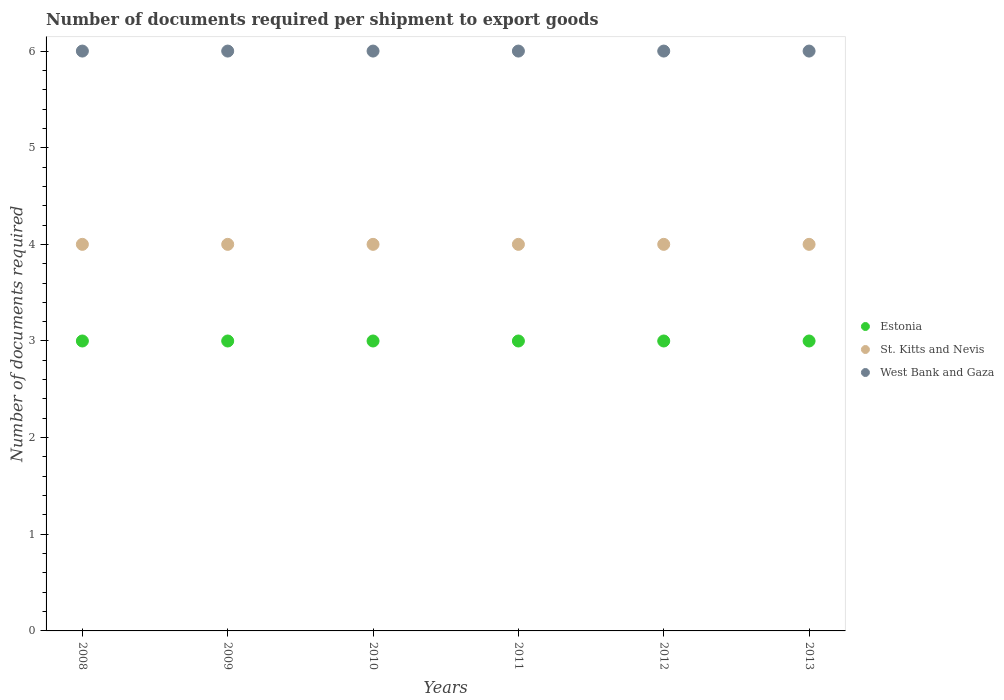How many different coloured dotlines are there?
Offer a terse response. 3. Is the number of dotlines equal to the number of legend labels?
Your answer should be very brief. Yes. In which year was the number of documents required per shipment to export goods in Estonia minimum?
Provide a short and direct response. 2008. What is the total number of documents required per shipment to export goods in St. Kitts and Nevis in the graph?
Provide a short and direct response. 24. What is the difference between the number of documents required per shipment to export goods in Estonia in 2008 and that in 2010?
Offer a terse response. 0. What is the difference between the number of documents required per shipment to export goods in West Bank and Gaza in 2013 and the number of documents required per shipment to export goods in St. Kitts and Nevis in 2012?
Make the answer very short. 2. In the year 2012, what is the difference between the number of documents required per shipment to export goods in Estonia and number of documents required per shipment to export goods in West Bank and Gaza?
Make the answer very short. -3. What is the ratio of the number of documents required per shipment to export goods in West Bank and Gaza in 2010 to that in 2011?
Provide a succinct answer. 1. Is the number of documents required per shipment to export goods in St. Kitts and Nevis in 2008 less than that in 2013?
Offer a very short reply. No. Is the difference between the number of documents required per shipment to export goods in Estonia in 2008 and 2009 greater than the difference between the number of documents required per shipment to export goods in West Bank and Gaza in 2008 and 2009?
Ensure brevity in your answer.  No. What is the difference between the highest and the second highest number of documents required per shipment to export goods in Estonia?
Your answer should be compact. 0. Is the sum of the number of documents required per shipment to export goods in Estonia in 2008 and 2013 greater than the maximum number of documents required per shipment to export goods in St. Kitts and Nevis across all years?
Provide a short and direct response. Yes. Is it the case that in every year, the sum of the number of documents required per shipment to export goods in St. Kitts and Nevis and number of documents required per shipment to export goods in Estonia  is greater than the number of documents required per shipment to export goods in West Bank and Gaza?
Ensure brevity in your answer.  Yes. Are the values on the major ticks of Y-axis written in scientific E-notation?
Provide a succinct answer. No. Does the graph contain grids?
Your response must be concise. No. Where does the legend appear in the graph?
Provide a short and direct response. Center right. How many legend labels are there?
Your answer should be very brief. 3. How are the legend labels stacked?
Ensure brevity in your answer.  Vertical. What is the title of the graph?
Your answer should be compact. Number of documents required per shipment to export goods. What is the label or title of the Y-axis?
Keep it short and to the point. Number of documents required. What is the Number of documents required of Estonia in 2008?
Provide a succinct answer. 3. What is the Number of documents required in West Bank and Gaza in 2008?
Offer a terse response. 6. What is the Number of documents required of Estonia in 2009?
Provide a short and direct response. 3. What is the Number of documents required of St. Kitts and Nevis in 2009?
Your answer should be very brief. 4. What is the Number of documents required in West Bank and Gaza in 2010?
Offer a terse response. 6. What is the Number of documents required of St. Kitts and Nevis in 2012?
Your answer should be very brief. 4. What is the Number of documents required in St. Kitts and Nevis in 2013?
Your answer should be compact. 4. Across all years, what is the maximum Number of documents required in Estonia?
Offer a very short reply. 3. Across all years, what is the maximum Number of documents required of St. Kitts and Nevis?
Keep it short and to the point. 4. Across all years, what is the minimum Number of documents required in Estonia?
Give a very brief answer. 3. Across all years, what is the minimum Number of documents required of St. Kitts and Nevis?
Your answer should be compact. 4. Across all years, what is the minimum Number of documents required of West Bank and Gaza?
Provide a succinct answer. 6. What is the total Number of documents required of St. Kitts and Nevis in the graph?
Make the answer very short. 24. What is the total Number of documents required in West Bank and Gaza in the graph?
Keep it short and to the point. 36. What is the difference between the Number of documents required of Estonia in 2008 and that in 2009?
Your answer should be compact. 0. What is the difference between the Number of documents required in St. Kitts and Nevis in 2008 and that in 2009?
Your answer should be compact. 0. What is the difference between the Number of documents required in West Bank and Gaza in 2008 and that in 2009?
Provide a succinct answer. 0. What is the difference between the Number of documents required of St. Kitts and Nevis in 2008 and that in 2010?
Your answer should be very brief. 0. What is the difference between the Number of documents required in West Bank and Gaza in 2008 and that in 2010?
Ensure brevity in your answer.  0. What is the difference between the Number of documents required in Estonia in 2008 and that in 2011?
Make the answer very short. 0. What is the difference between the Number of documents required of Estonia in 2008 and that in 2012?
Give a very brief answer. 0. What is the difference between the Number of documents required in West Bank and Gaza in 2009 and that in 2010?
Provide a succinct answer. 0. What is the difference between the Number of documents required in Estonia in 2009 and that in 2011?
Your response must be concise. 0. What is the difference between the Number of documents required of West Bank and Gaza in 2009 and that in 2011?
Provide a short and direct response. 0. What is the difference between the Number of documents required in West Bank and Gaza in 2009 and that in 2012?
Provide a short and direct response. 0. What is the difference between the Number of documents required in West Bank and Gaza in 2009 and that in 2013?
Your answer should be very brief. 0. What is the difference between the Number of documents required in Estonia in 2010 and that in 2011?
Offer a terse response. 0. What is the difference between the Number of documents required of West Bank and Gaza in 2010 and that in 2011?
Provide a succinct answer. 0. What is the difference between the Number of documents required of West Bank and Gaza in 2010 and that in 2012?
Offer a very short reply. 0. What is the difference between the Number of documents required of Estonia in 2011 and that in 2013?
Your answer should be compact. 0. What is the difference between the Number of documents required in St. Kitts and Nevis in 2011 and that in 2013?
Your response must be concise. 0. What is the difference between the Number of documents required of St. Kitts and Nevis in 2012 and that in 2013?
Offer a terse response. 0. What is the difference between the Number of documents required in St. Kitts and Nevis in 2008 and the Number of documents required in West Bank and Gaza in 2009?
Ensure brevity in your answer.  -2. What is the difference between the Number of documents required in Estonia in 2008 and the Number of documents required in West Bank and Gaza in 2010?
Offer a very short reply. -3. What is the difference between the Number of documents required in Estonia in 2008 and the Number of documents required in St. Kitts and Nevis in 2011?
Ensure brevity in your answer.  -1. What is the difference between the Number of documents required in St. Kitts and Nevis in 2008 and the Number of documents required in West Bank and Gaza in 2011?
Offer a very short reply. -2. What is the difference between the Number of documents required of Estonia in 2008 and the Number of documents required of West Bank and Gaza in 2012?
Your answer should be compact. -3. What is the difference between the Number of documents required in St. Kitts and Nevis in 2008 and the Number of documents required in West Bank and Gaza in 2012?
Ensure brevity in your answer.  -2. What is the difference between the Number of documents required of St. Kitts and Nevis in 2008 and the Number of documents required of West Bank and Gaza in 2013?
Ensure brevity in your answer.  -2. What is the difference between the Number of documents required in St. Kitts and Nevis in 2009 and the Number of documents required in West Bank and Gaza in 2010?
Provide a succinct answer. -2. What is the difference between the Number of documents required in Estonia in 2009 and the Number of documents required in West Bank and Gaza in 2011?
Make the answer very short. -3. What is the difference between the Number of documents required in Estonia in 2009 and the Number of documents required in St. Kitts and Nevis in 2012?
Offer a terse response. -1. What is the difference between the Number of documents required in Estonia in 2009 and the Number of documents required in West Bank and Gaza in 2012?
Your response must be concise. -3. What is the difference between the Number of documents required in St. Kitts and Nevis in 2009 and the Number of documents required in West Bank and Gaza in 2012?
Your answer should be compact. -2. What is the difference between the Number of documents required in Estonia in 2009 and the Number of documents required in St. Kitts and Nevis in 2013?
Your answer should be compact. -1. What is the difference between the Number of documents required of St. Kitts and Nevis in 2010 and the Number of documents required of West Bank and Gaza in 2011?
Provide a short and direct response. -2. What is the difference between the Number of documents required of Estonia in 2010 and the Number of documents required of West Bank and Gaza in 2012?
Give a very brief answer. -3. What is the difference between the Number of documents required of St. Kitts and Nevis in 2010 and the Number of documents required of West Bank and Gaza in 2012?
Offer a very short reply. -2. What is the difference between the Number of documents required in Estonia in 2010 and the Number of documents required in West Bank and Gaza in 2013?
Provide a succinct answer. -3. What is the difference between the Number of documents required of St. Kitts and Nevis in 2010 and the Number of documents required of West Bank and Gaza in 2013?
Your answer should be very brief. -2. What is the difference between the Number of documents required of St. Kitts and Nevis in 2011 and the Number of documents required of West Bank and Gaza in 2012?
Your answer should be very brief. -2. What is the difference between the Number of documents required of Estonia in 2011 and the Number of documents required of St. Kitts and Nevis in 2013?
Offer a very short reply. -1. What is the difference between the Number of documents required of Estonia in 2011 and the Number of documents required of West Bank and Gaza in 2013?
Offer a very short reply. -3. What is the difference between the Number of documents required of St. Kitts and Nevis in 2011 and the Number of documents required of West Bank and Gaza in 2013?
Offer a terse response. -2. What is the difference between the Number of documents required in St. Kitts and Nevis in 2012 and the Number of documents required in West Bank and Gaza in 2013?
Make the answer very short. -2. What is the average Number of documents required in Estonia per year?
Provide a short and direct response. 3. What is the average Number of documents required in West Bank and Gaza per year?
Make the answer very short. 6. In the year 2008, what is the difference between the Number of documents required in Estonia and Number of documents required in St. Kitts and Nevis?
Your answer should be compact. -1. In the year 2009, what is the difference between the Number of documents required of Estonia and Number of documents required of St. Kitts and Nevis?
Make the answer very short. -1. In the year 2009, what is the difference between the Number of documents required of Estonia and Number of documents required of West Bank and Gaza?
Give a very brief answer. -3. In the year 2009, what is the difference between the Number of documents required in St. Kitts and Nevis and Number of documents required in West Bank and Gaza?
Keep it short and to the point. -2. In the year 2010, what is the difference between the Number of documents required of Estonia and Number of documents required of St. Kitts and Nevis?
Provide a succinct answer. -1. In the year 2010, what is the difference between the Number of documents required in Estonia and Number of documents required in West Bank and Gaza?
Provide a short and direct response. -3. In the year 2011, what is the difference between the Number of documents required in St. Kitts and Nevis and Number of documents required in West Bank and Gaza?
Provide a short and direct response. -2. In the year 2012, what is the difference between the Number of documents required of Estonia and Number of documents required of St. Kitts and Nevis?
Ensure brevity in your answer.  -1. In the year 2012, what is the difference between the Number of documents required of St. Kitts and Nevis and Number of documents required of West Bank and Gaza?
Ensure brevity in your answer.  -2. In the year 2013, what is the difference between the Number of documents required of St. Kitts and Nevis and Number of documents required of West Bank and Gaza?
Your response must be concise. -2. What is the ratio of the Number of documents required in Estonia in 2008 to that in 2009?
Offer a very short reply. 1. What is the ratio of the Number of documents required in St. Kitts and Nevis in 2008 to that in 2010?
Your response must be concise. 1. What is the ratio of the Number of documents required of Estonia in 2008 to that in 2011?
Your response must be concise. 1. What is the ratio of the Number of documents required of West Bank and Gaza in 2008 to that in 2012?
Give a very brief answer. 1. What is the ratio of the Number of documents required of Estonia in 2008 to that in 2013?
Provide a succinct answer. 1. What is the ratio of the Number of documents required in West Bank and Gaza in 2008 to that in 2013?
Provide a short and direct response. 1. What is the ratio of the Number of documents required in St. Kitts and Nevis in 2009 to that in 2010?
Give a very brief answer. 1. What is the ratio of the Number of documents required of West Bank and Gaza in 2009 to that in 2010?
Give a very brief answer. 1. What is the ratio of the Number of documents required in Estonia in 2009 to that in 2011?
Keep it short and to the point. 1. What is the ratio of the Number of documents required of St. Kitts and Nevis in 2009 to that in 2011?
Ensure brevity in your answer.  1. What is the ratio of the Number of documents required in West Bank and Gaza in 2009 to that in 2011?
Your response must be concise. 1. What is the ratio of the Number of documents required of Estonia in 2009 to that in 2013?
Provide a succinct answer. 1. What is the ratio of the Number of documents required of St. Kitts and Nevis in 2009 to that in 2013?
Give a very brief answer. 1. What is the ratio of the Number of documents required of West Bank and Gaza in 2010 to that in 2011?
Ensure brevity in your answer.  1. What is the ratio of the Number of documents required of Estonia in 2010 to that in 2012?
Provide a succinct answer. 1. What is the ratio of the Number of documents required of St. Kitts and Nevis in 2010 to that in 2012?
Offer a terse response. 1. What is the ratio of the Number of documents required of West Bank and Gaza in 2010 to that in 2013?
Your answer should be very brief. 1. What is the ratio of the Number of documents required in St. Kitts and Nevis in 2011 to that in 2012?
Provide a short and direct response. 1. What is the ratio of the Number of documents required of Estonia in 2011 to that in 2013?
Offer a terse response. 1. What is the ratio of the Number of documents required of St. Kitts and Nevis in 2011 to that in 2013?
Make the answer very short. 1. What is the ratio of the Number of documents required in Estonia in 2012 to that in 2013?
Keep it short and to the point. 1. What is the ratio of the Number of documents required in St. Kitts and Nevis in 2012 to that in 2013?
Your answer should be compact. 1. What is the difference between the highest and the second highest Number of documents required in Estonia?
Provide a short and direct response. 0. What is the difference between the highest and the second highest Number of documents required of St. Kitts and Nevis?
Offer a terse response. 0. What is the difference between the highest and the second highest Number of documents required in West Bank and Gaza?
Give a very brief answer. 0. What is the difference between the highest and the lowest Number of documents required of Estonia?
Ensure brevity in your answer.  0. What is the difference between the highest and the lowest Number of documents required of St. Kitts and Nevis?
Give a very brief answer. 0. 